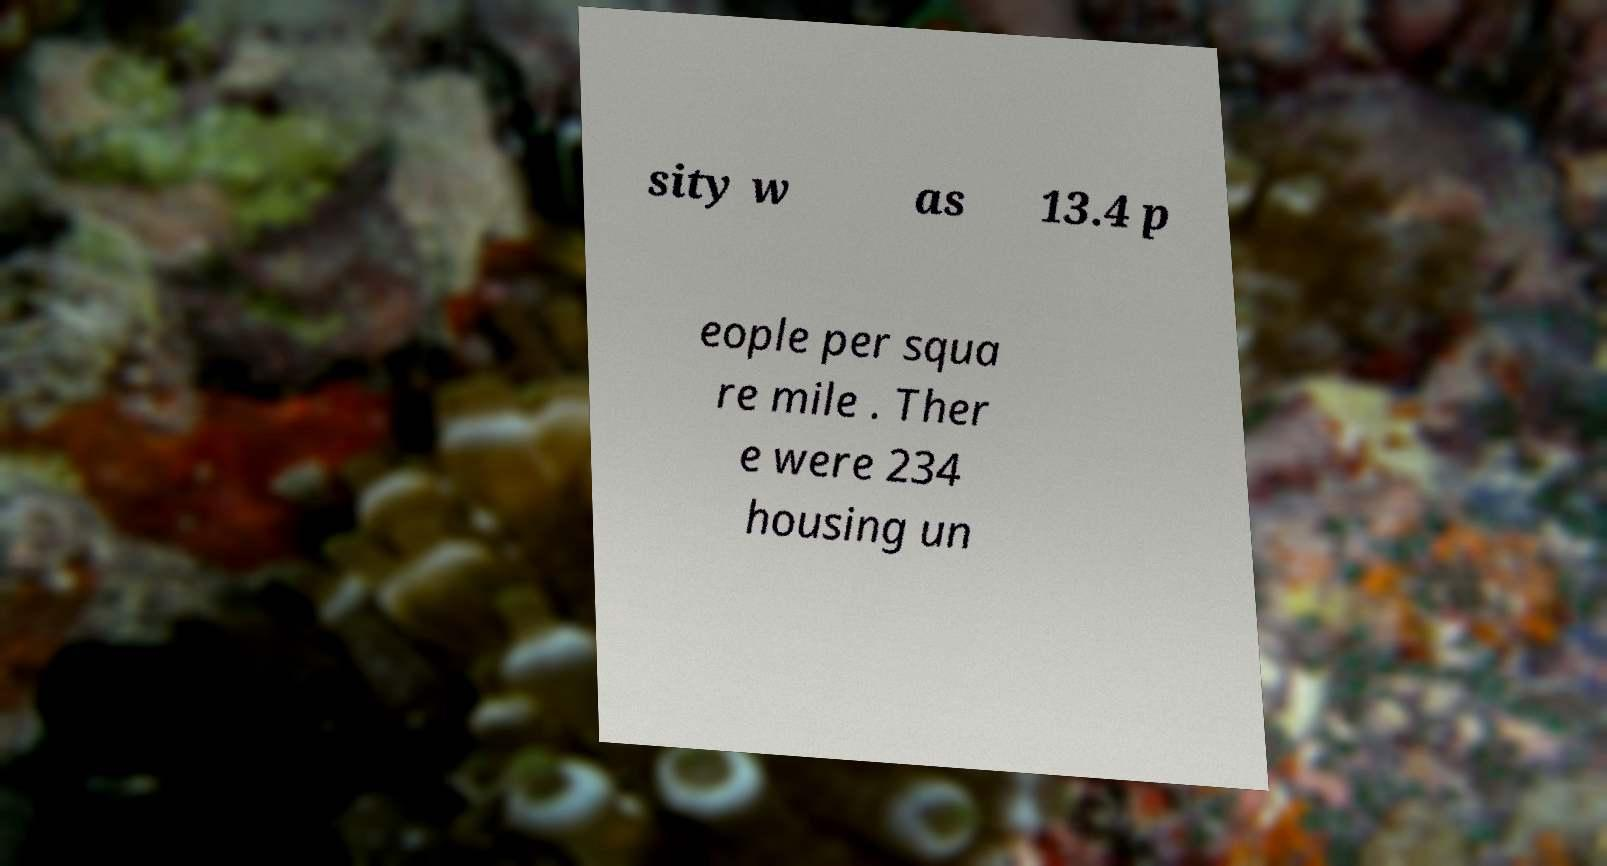There's text embedded in this image that I need extracted. Can you transcribe it verbatim? sity w as 13.4 p eople per squa re mile . Ther e were 234 housing un 